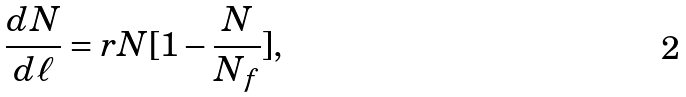Convert formula to latex. <formula><loc_0><loc_0><loc_500><loc_500>\frac { d N } { d \ell } = r N [ 1 - \frac { N } { N _ { f } } ] ,</formula> 